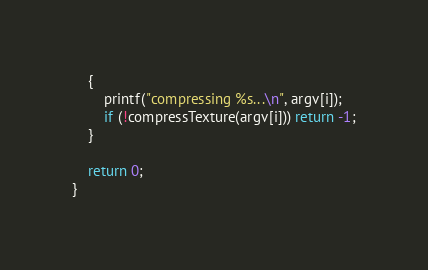<code> <loc_0><loc_0><loc_500><loc_500><_C++_>	{
		printf("compressing %s...\n", argv[i]);
		if (!compressTexture(argv[i])) return -1;
	}
	
	return 0;
}
</code> 